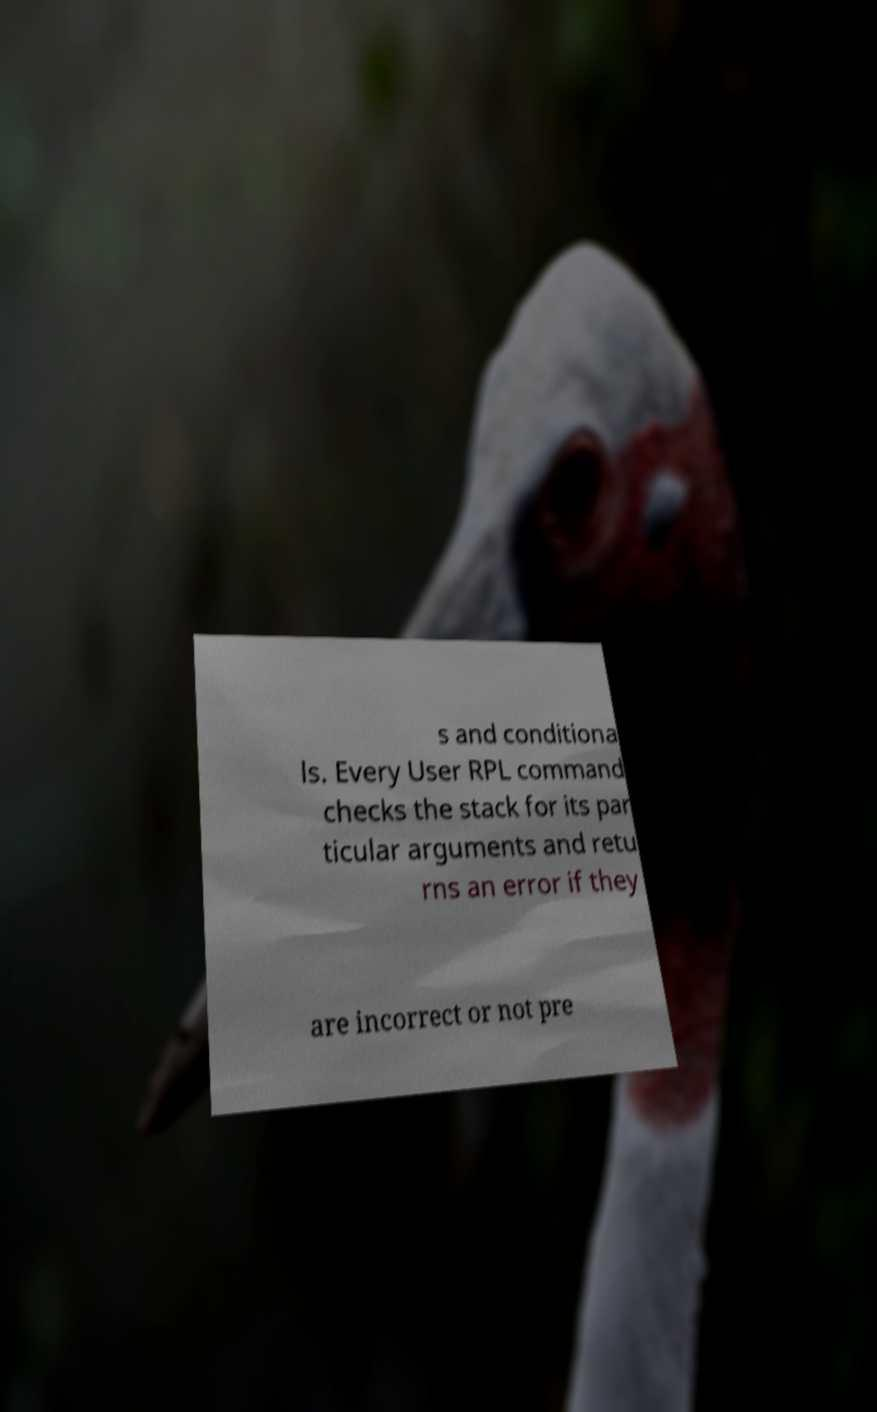What messages or text are displayed in this image? I need them in a readable, typed format. s and conditiona ls. Every User RPL command checks the stack for its par ticular arguments and retu rns an error if they are incorrect or not pre 